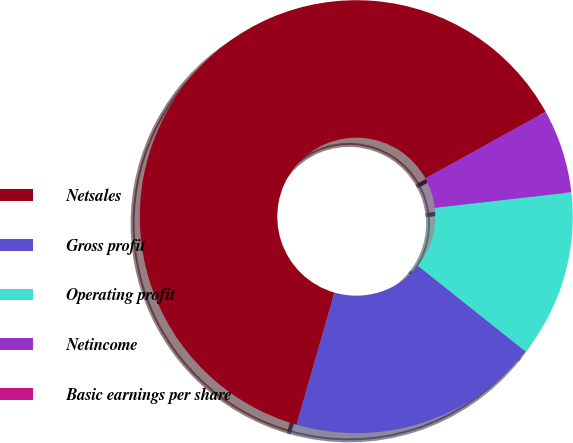Convert chart to OTSL. <chart><loc_0><loc_0><loc_500><loc_500><pie_chart><fcel>Netsales<fcel>Gross profit<fcel>Operating profit<fcel>Netincome<fcel>Basic earnings per share<nl><fcel>62.5%<fcel>18.75%<fcel>12.5%<fcel>6.25%<fcel>0.0%<nl></chart> 